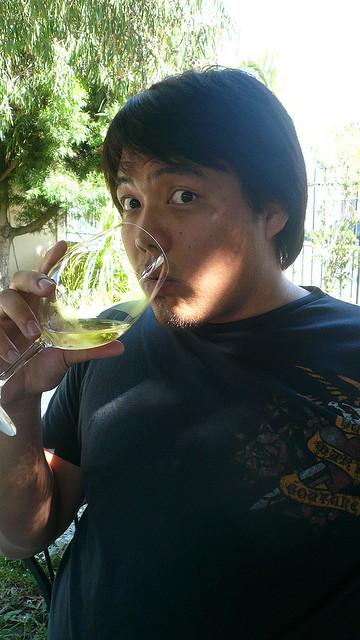Does this guy have big eyes?
Concise answer only. Yes. What is this guy doing?
Answer briefly. Drinking. What type of wine is he drinking?
Answer briefly. White. 